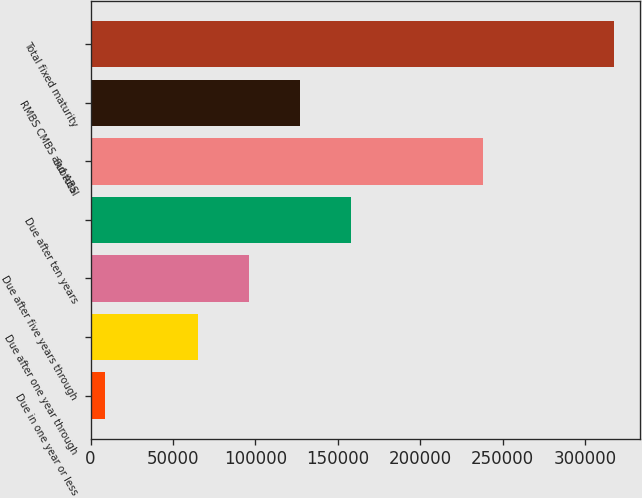Convert chart to OTSL. <chart><loc_0><loc_0><loc_500><loc_500><bar_chart><fcel>Due in one year or less<fcel>Due after one year through<fcel>Due after five years through<fcel>Due after ten years<fcel>Subtotal<fcel>RMBS CMBS and ABS<fcel>Total fixed maturity<nl><fcel>8580<fcel>65143<fcel>96046.7<fcel>157854<fcel>238214<fcel>126950<fcel>317617<nl></chart> 